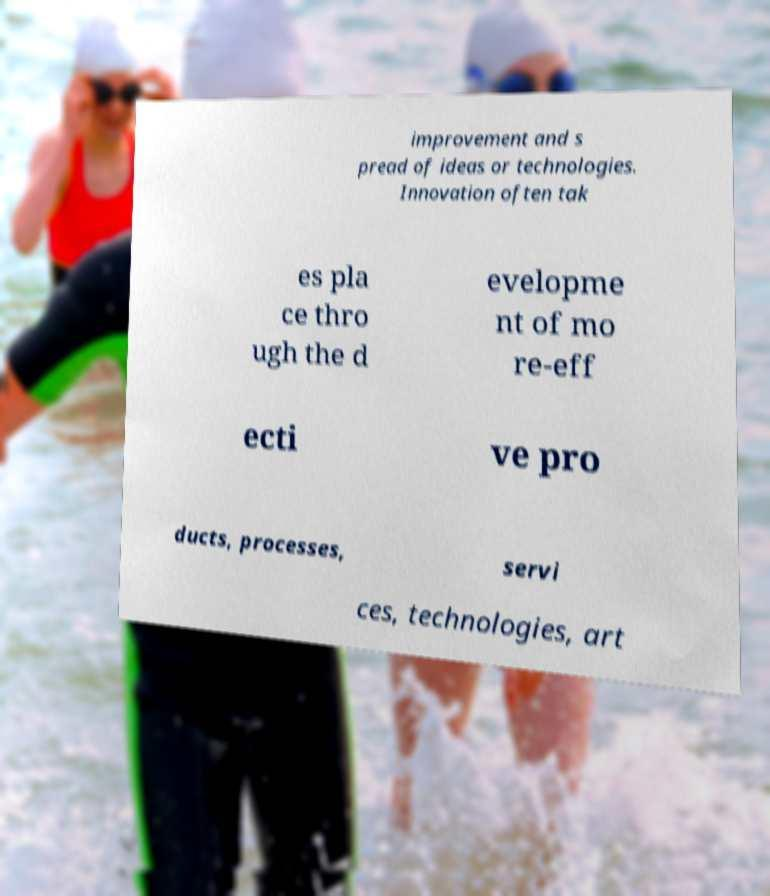Could you assist in decoding the text presented in this image and type it out clearly? improvement and s pread of ideas or technologies. Innovation often tak es pla ce thro ugh the d evelopme nt of mo re-eff ecti ve pro ducts, processes, servi ces, technologies, art 